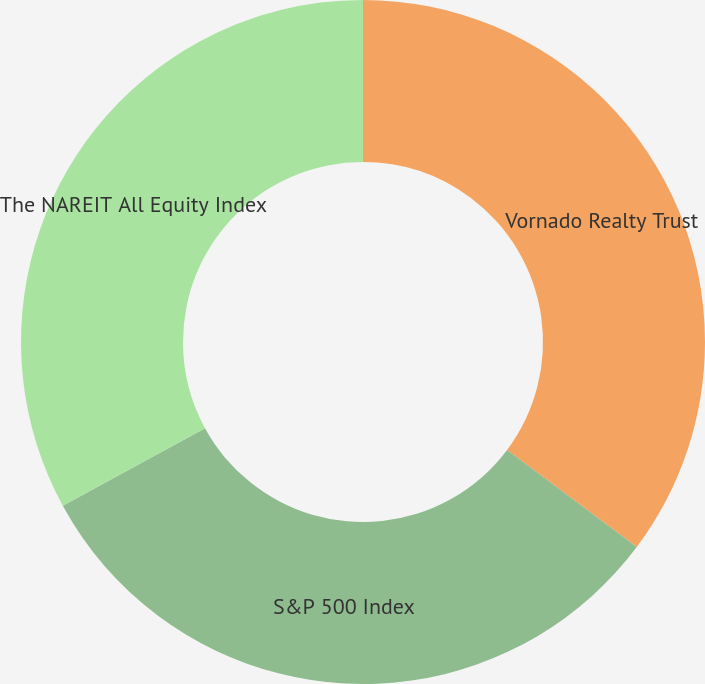Convert chart to OTSL. <chart><loc_0><loc_0><loc_500><loc_500><pie_chart><fcel>Vornado Realty Trust<fcel>S&P 500 Index<fcel>The NAREIT All Equity Index<nl><fcel>35.23%<fcel>31.82%<fcel>32.95%<nl></chart> 